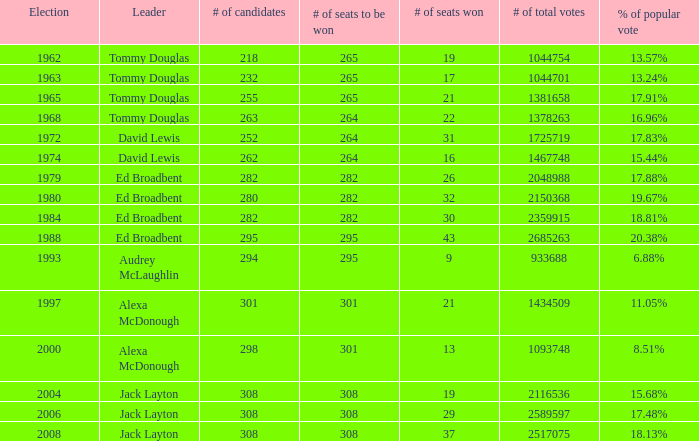Could you parse the entire table as a dict? {'header': ['Election', 'Leader', '# of candidates', '# of seats to be won', '# of seats won', '# of total votes', '% of popular vote'], 'rows': [['1962', 'Tommy Douglas', '218', '265', '19', '1044754', '13.57%'], ['1963', 'Tommy Douglas', '232', '265', '17', '1044701', '13.24%'], ['1965', 'Tommy Douglas', '255', '265', '21', '1381658', '17.91%'], ['1968', 'Tommy Douglas', '263', '264', '22', '1378263', '16.96%'], ['1972', 'David Lewis', '252', '264', '31', '1725719', '17.83%'], ['1974', 'David Lewis', '262', '264', '16', '1467748', '15.44%'], ['1979', 'Ed Broadbent', '282', '282', '26', '2048988', '17.88%'], ['1980', 'Ed Broadbent', '280', '282', '32', '2150368', '19.67%'], ['1984', 'Ed Broadbent', '282', '282', '30', '2359915', '18.81%'], ['1988', 'Ed Broadbent', '295', '295', '43', '2685263', '20.38%'], ['1993', 'Audrey McLaughlin', '294', '295', '9', '933688', '6.88%'], ['1997', 'Alexa McDonough', '301', '301', '21', '1434509', '11.05%'], ['2000', 'Alexa McDonough', '298', '301', '13', '1093748', '8.51%'], ['2004', 'Jack Layton', '308', '308', '19', '2116536', '15.68%'], ['2006', 'Jack Layton', '308', '308', '29', '2589597', '17.48%'], ['2008', 'Jack Layton', '308', '308', '37', '2517075', '18.13%']]} 88% share of the total vote. 295.0. 